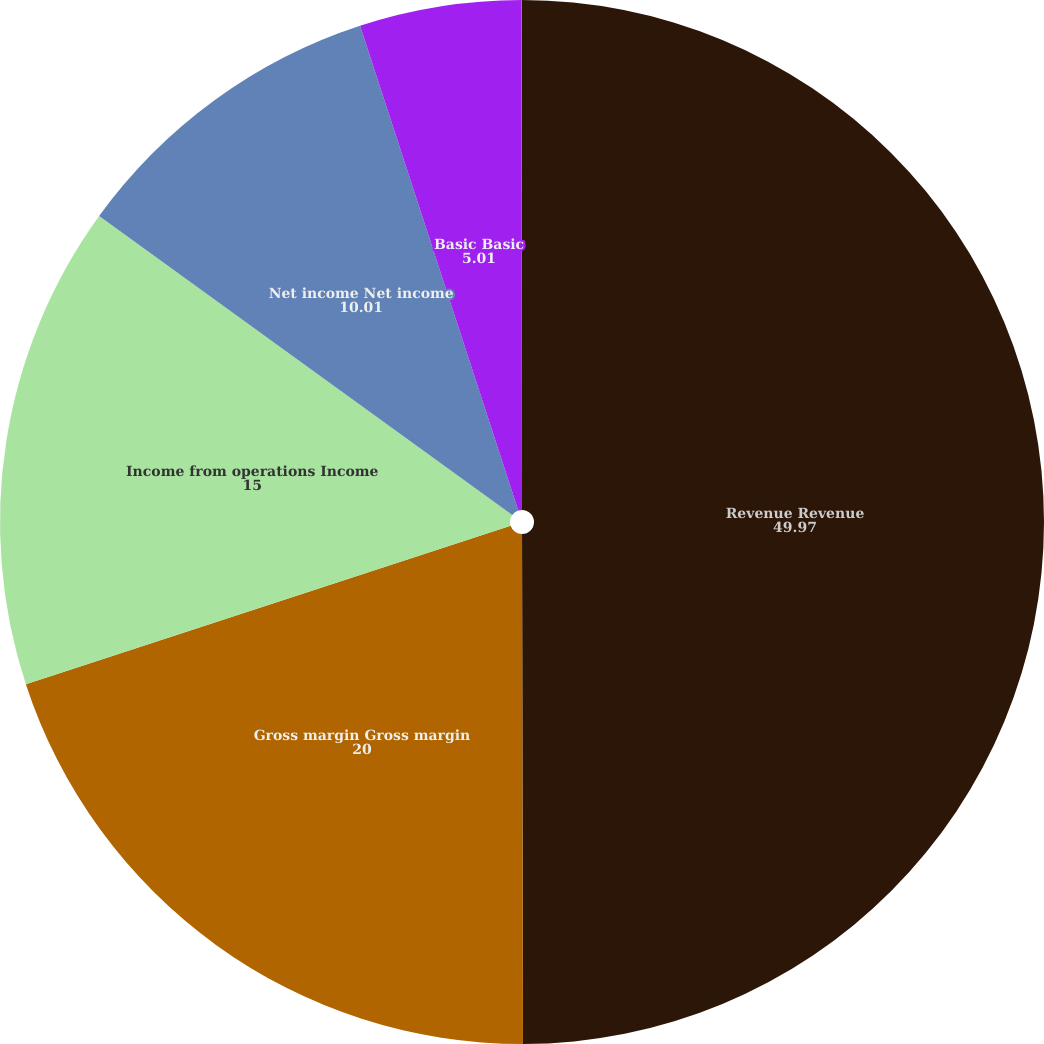<chart> <loc_0><loc_0><loc_500><loc_500><pie_chart><fcel>Revenue Revenue<fcel>Gross margin Gross margin<fcel>Income from operations Income<fcel>Net income Net income<fcel>Basic Basic<fcel>Diluted Diluted<nl><fcel>49.97%<fcel>20.0%<fcel>15.0%<fcel>10.01%<fcel>5.01%<fcel>0.01%<nl></chart> 